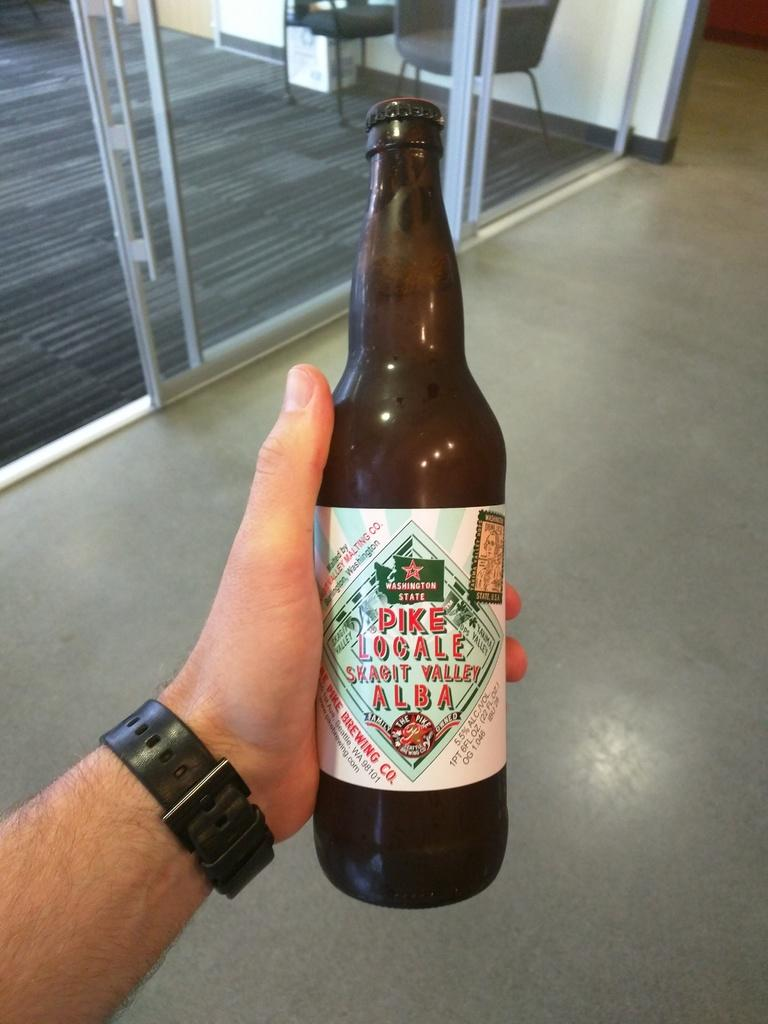What object is being held by a person in the image? There is a brown bottle in the image, and a person is holding it. What type of structure can be seen in the image? There is a door in the image. What type of furniture is present in the image? There is a chair in the image. What type of road can be seen in the image? There is no road present in the image. What button is being pressed by the person holding the bottle? There is no button visible in the image. 